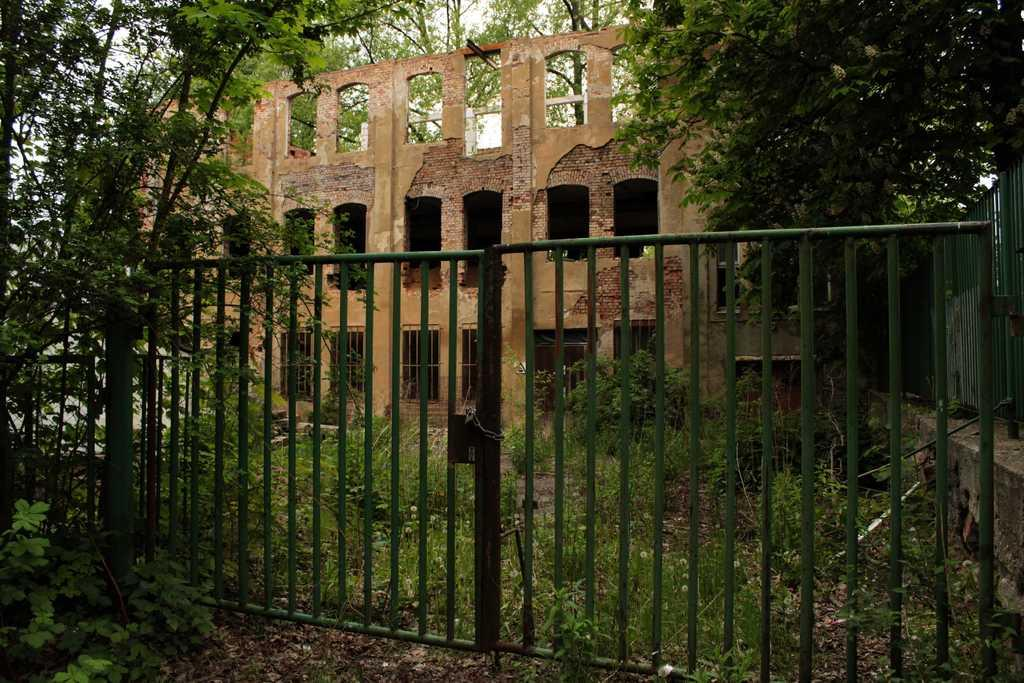What is located at the front of the image? There is a gate in the image. Where are the trees and buildings in relation to the gate? The trees and buildings are in the background of the image. What type of food can be seen on the gate in the image? There is no food present on the gate in the image. Can you describe the insects that are crawling on the trees in the background? There are no insects visible on the trees in the image. 